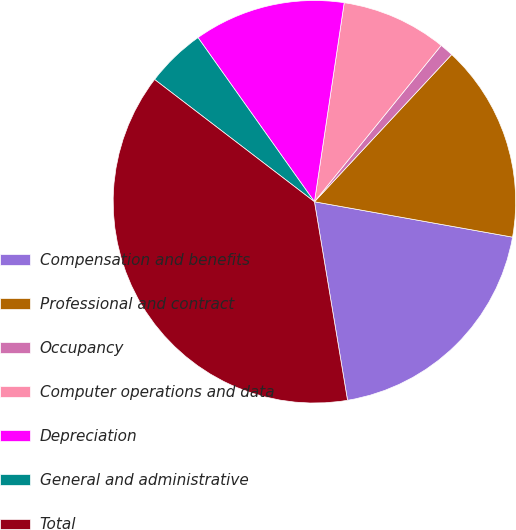Convert chart to OTSL. <chart><loc_0><loc_0><loc_500><loc_500><pie_chart><fcel>Compensation and benefits<fcel>Professional and contract<fcel>Occupancy<fcel>Computer operations and data<fcel>Depreciation<fcel>General and administrative<fcel>Total<nl><fcel>19.56%<fcel>15.87%<fcel>1.1%<fcel>8.48%<fcel>12.18%<fcel>4.79%<fcel>38.02%<nl></chart> 